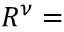<formula> <loc_0><loc_0><loc_500><loc_500>R ^ { \nu } =</formula> 